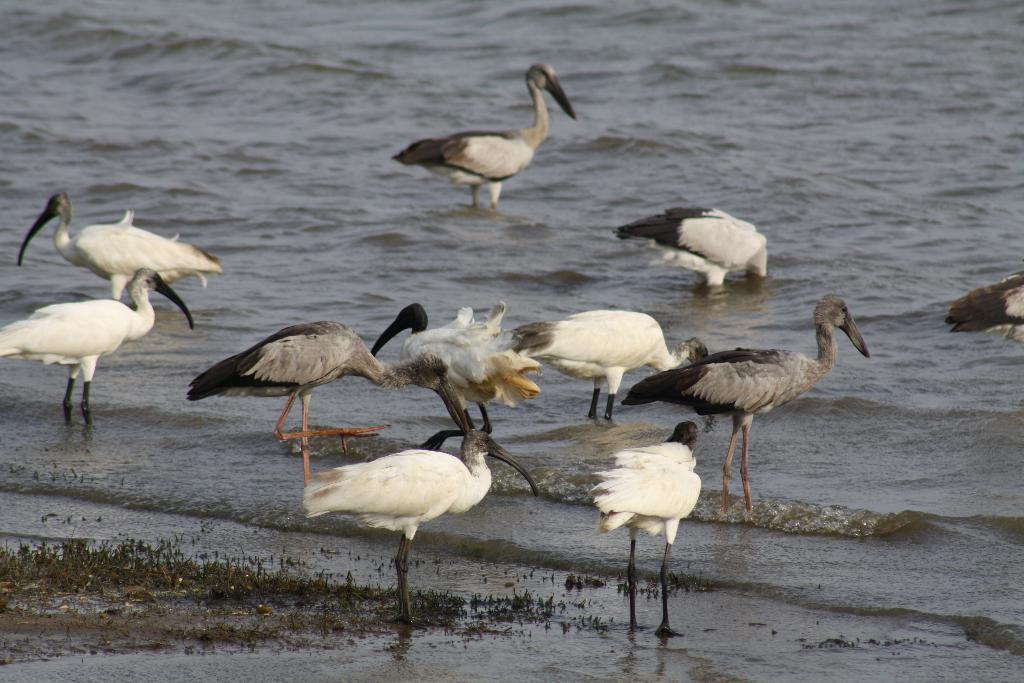How would you summarize this image in a sentence or two? There is water. In that there are different cranes. On the left side there is something on the sea shore. 